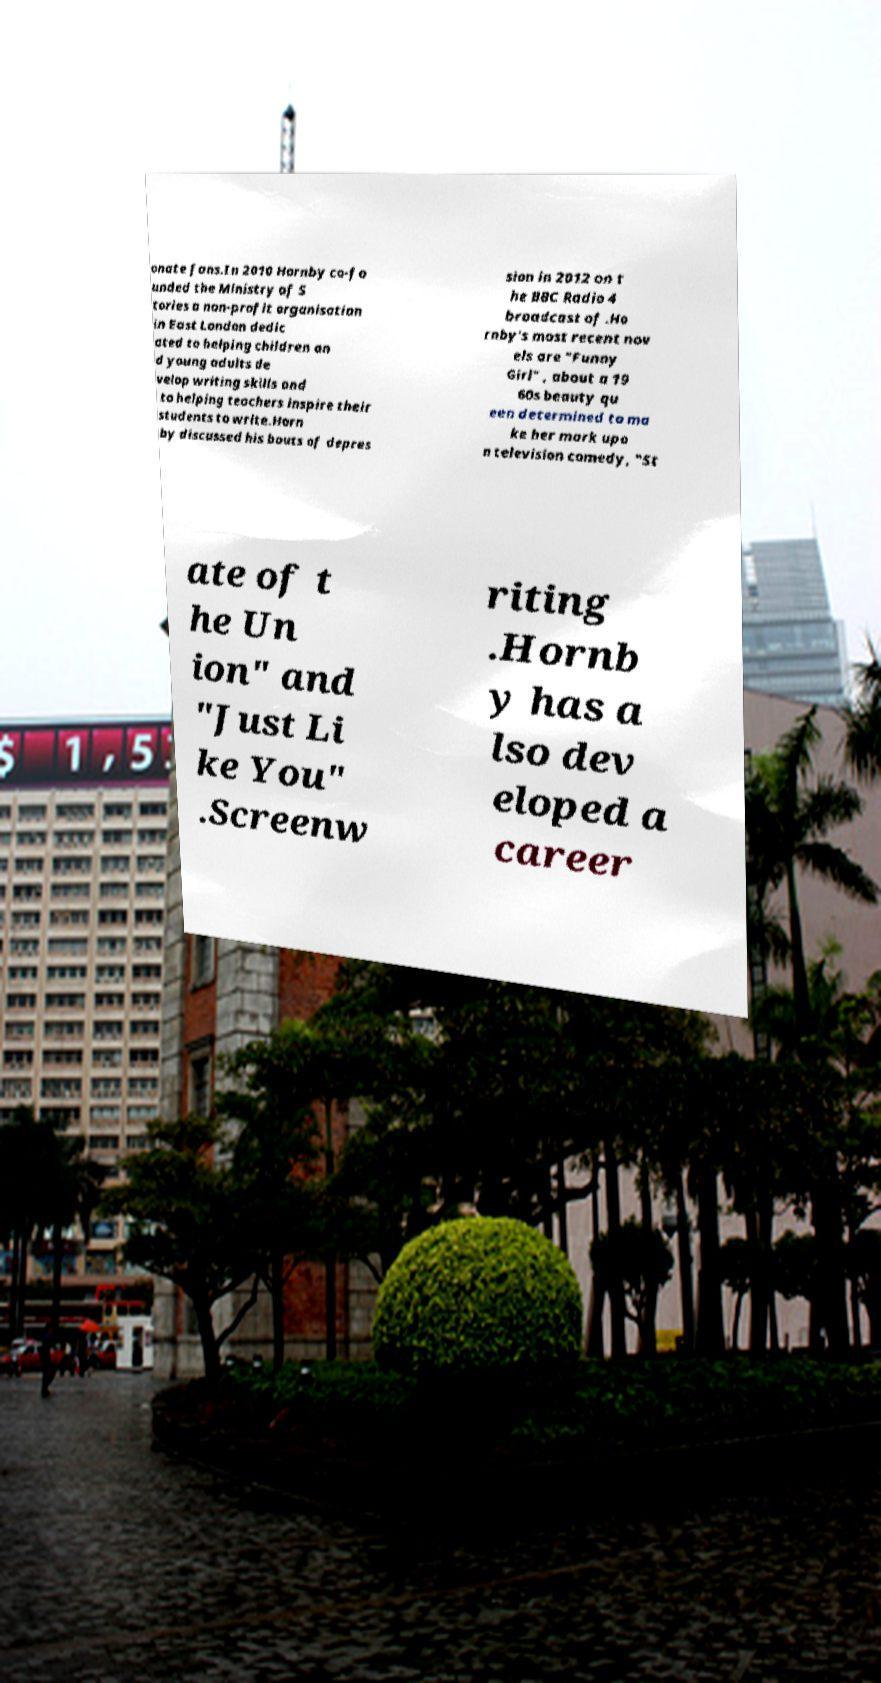Can you accurately transcribe the text from the provided image for me? onate fans.In 2010 Hornby co-fo unded the Ministry of S tories a non-profit organisation in East London dedic ated to helping children an d young adults de velop writing skills and to helping teachers inspire their students to write.Horn by discussed his bouts of depres sion in 2012 on t he BBC Radio 4 broadcast of .Ho rnby's most recent nov els are "Funny Girl" , about a 19 60s beauty qu een determined to ma ke her mark upo n television comedy, "St ate of t he Un ion" and "Just Li ke You" .Screenw riting .Hornb y has a lso dev eloped a career 